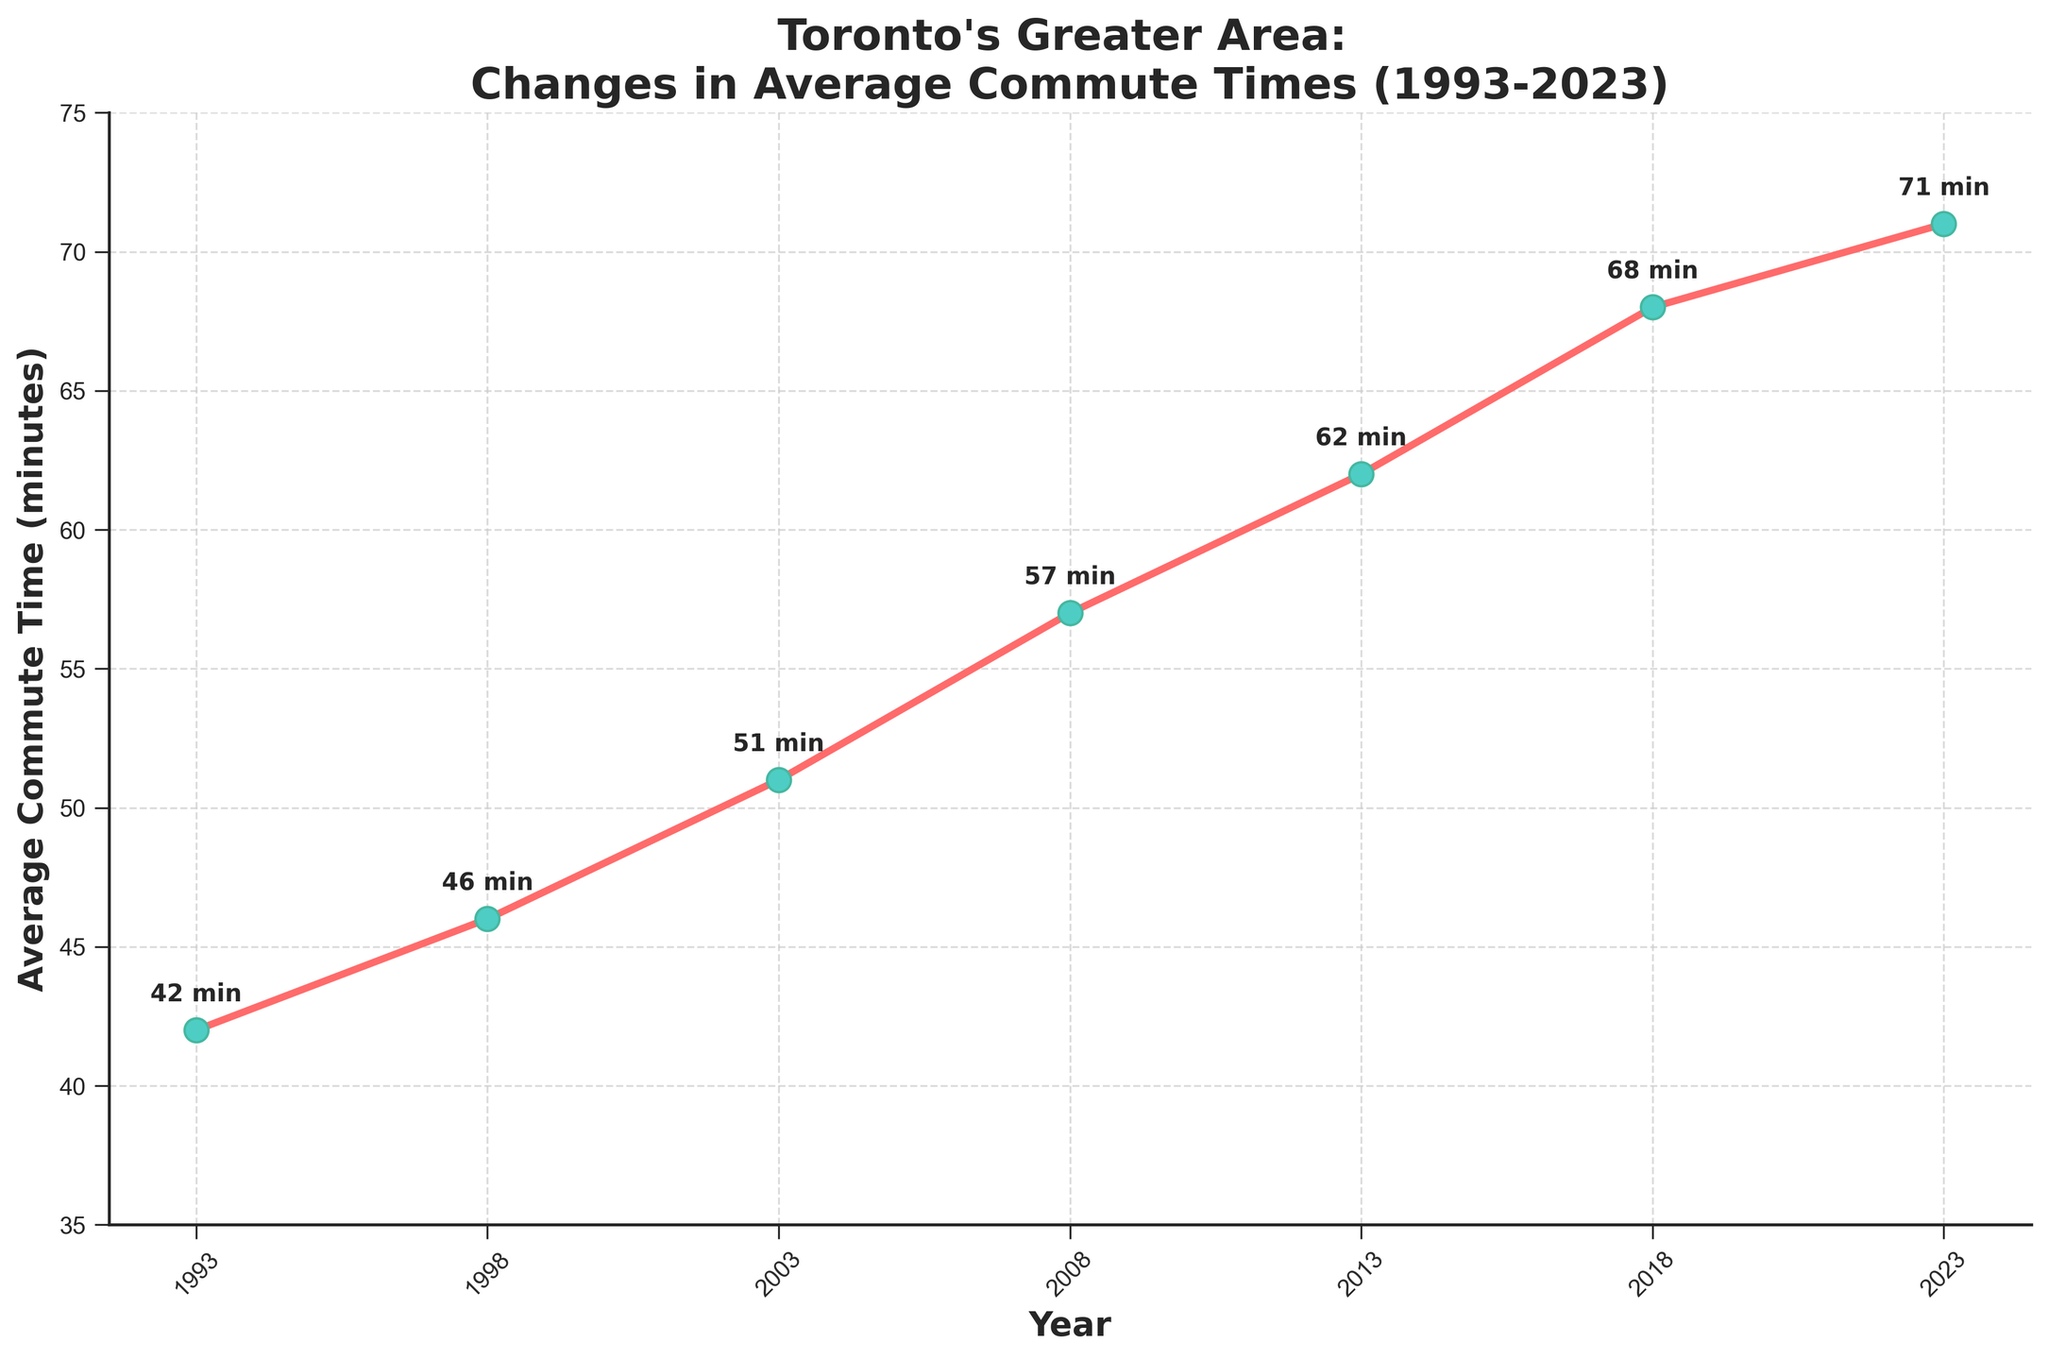What was the average commute time in 2003? The point on the line chart corresponding to the year 2003 shows an average commute time of 51 minutes.
Answer: 51 minutes How much did the average commute time increase between 1993 and 2023? The average commute time in 1993 was 42 minutes, and by 2023 it had increased to 71 minutes, so the increase is 71 - 42 = 29 minutes.
Answer: 29 minutes In which year did the average commute time surpass 50 minutes? The average commute time was 51 minutes in 2003, so it surpassed 50 minutes in 2003.
Answer: 2003 Which year experienced the largest increase in average commute time from the previous data point? By comparing the differences between consecutive years: 
1993 to 1998 (46 - 42 = 4), 
1998 to 2003 (51 - 46 = 5), 
2003 to 2008 (57 - 51 = 6), 
2008 to 2013 (62 - 57 = 5), 
2013 to 2018 (68 - 62 = 6), 
2018 to 2023 (71 - 68 = 3). 
The largest increase was 6 minutes from 2003 to 2008 and 2013 to 2018.
Answer: 2003 to 2008, 2013 to 2018 What is the average commute time across all the years shown? Adding the average commute times: 42 + 46 + 51 + 57 + 62 + 68 + 71 = 397. There are 7 data points, so the average is 397 / 7 ≈ 56.7 minutes.
Answer: 56.7 minutes What was the percentage increase in average commute time from 2008 to 2013? The average commute time increased from 57 minutes in 2008 to 62 minutes in 2013. The increase is 62 - 57 = 5 minutes. The percentage increase is (5 / 57) * 100 ≈ 8.77%.
Answer: 8.77% Which two consecutive years had the smallest increase in average commute time? By comparing the differences between consecutive years: 
1993 to 1998 (46 - 42 = 4), 
1998 to 2003 (51 - 46 = 5), 
2003 to 2008 (57 - 51 = 6), 
2008 to 2013 (62 - 57 = 5), 
2013 to 2018 (68 - 62 = 6), 
2018 to 2023 (71 - 68 = 3), 
the smallest increase is between 2018 to 2023 (3 minutes).
Answer: 2018 to 2023 Which year had the highest average commute time? The highest point on the line chart represents the year 2023 with an average commute time of 71 minutes.
Answer: 2023 How does the average commute time in 1998 compare to that in 2018? In 1998, the average commute time was 46 minutes, while in 2018, it was 68 minutes. So, the 2018 commute time is greater than the 1998 commute time by 68 - 46 = 22 minutes.
Answer: 2018 is 22 minutes longer 